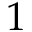<formula> <loc_0><loc_0><loc_500><loc_500>1</formula> 